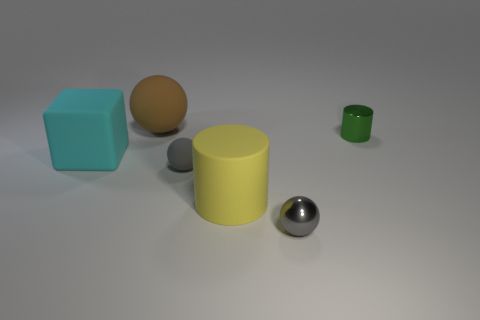Is there any other thing that has the same shape as the large cyan thing?
Give a very brief answer. No. Are the cylinder that is in front of the cube and the tiny cylinder made of the same material?
Provide a short and direct response. No. Are there any small matte things of the same color as the tiny shiny sphere?
Ensure brevity in your answer.  Yes. Are any gray rubber things visible?
Provide a short and direct response. Yes. Is the size of the matte sphere that is behind the gray rubber ball the same as the large block?
Provide a short and direct response. Yes. Are there fewer yellow rubber things than large rubber things?
Make the answer very short. Yes. What is the shape of the shiny object that is left of the shiny thing that is behind the small metal thing left of the green cylinder?
Your response must be concise. Sphere. Is there a purple sphere made of the same material as the large yellow thing?
Give a very brief answer. No. Does the metallic object in front of the tiny green thing have the same color as the small sphere that is behind the yellow object?
Offer a very short reply. Yes. Are there fewer small rubber spheres behind the brown rubber sphere than rubber cylinders?
Your response must be concise. Yes. 